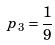Convert formula to latex. <formula><loc_0><loc_0><loc_500><loc_500>p _ { 3 } = \frac { 1 } { 9 }</formula> 